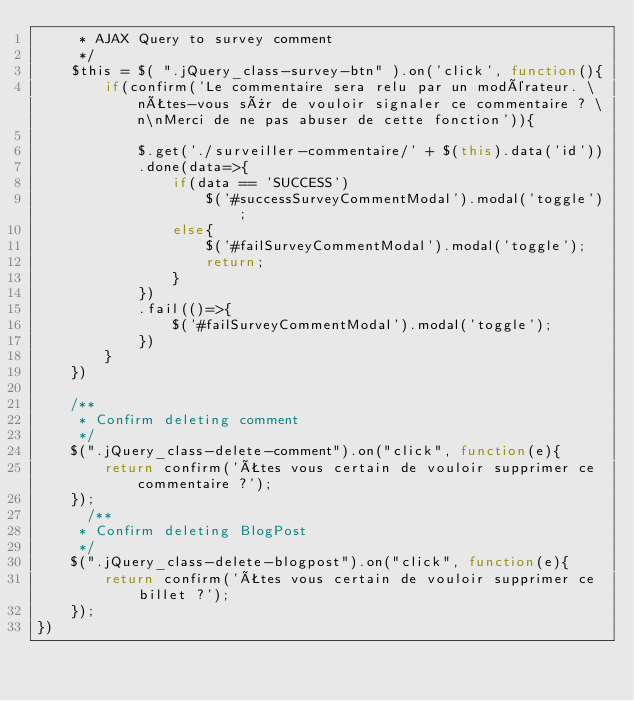<code> <loc_0><loc_0><loc_500><loc_500><_JavaScript_>     * AJAX Query to survey comment
     */
    $this = $( ".jQuery_class-survey-btn" ).on('click', function(){
        if(confirm('Le commentaire sera relu par un modérateur. \nÊtes-vous sûr de vouloir signaler ce commentaire ? \n\nMerci de ne pas abuser de cette fonction')){
            
            $.get('./surveiller-commentaire/' + $(this).data('id'))
            .done(data=>{
                if(data == 'SUCCESS')
                    $('#successSurveyCommentModal').modal('toggle');
                else{
                    $('#failSurveyCommentModal').modal('toggle');
                    return;
                }
            })
            .fail(()=>{
                $('#failSurveyCommentModal').modal('toggle');
            })
        }
    })

    /**
     * Confirm deleting comment
     */
    $(".jQuery_class-delete-comment").on("click", function(e){
        return confirm('Êtes vous certain de vouloir supprimer ce commentaire ?');
    });
      /**
     * Confirm deleting BlogPost
     */
    $(".jQuery_class-delete-blogpost").on("click", function(e){
        return confirm('Êtes vous certain de vouloir supprimer ce billet ?');
    });
})</code> 